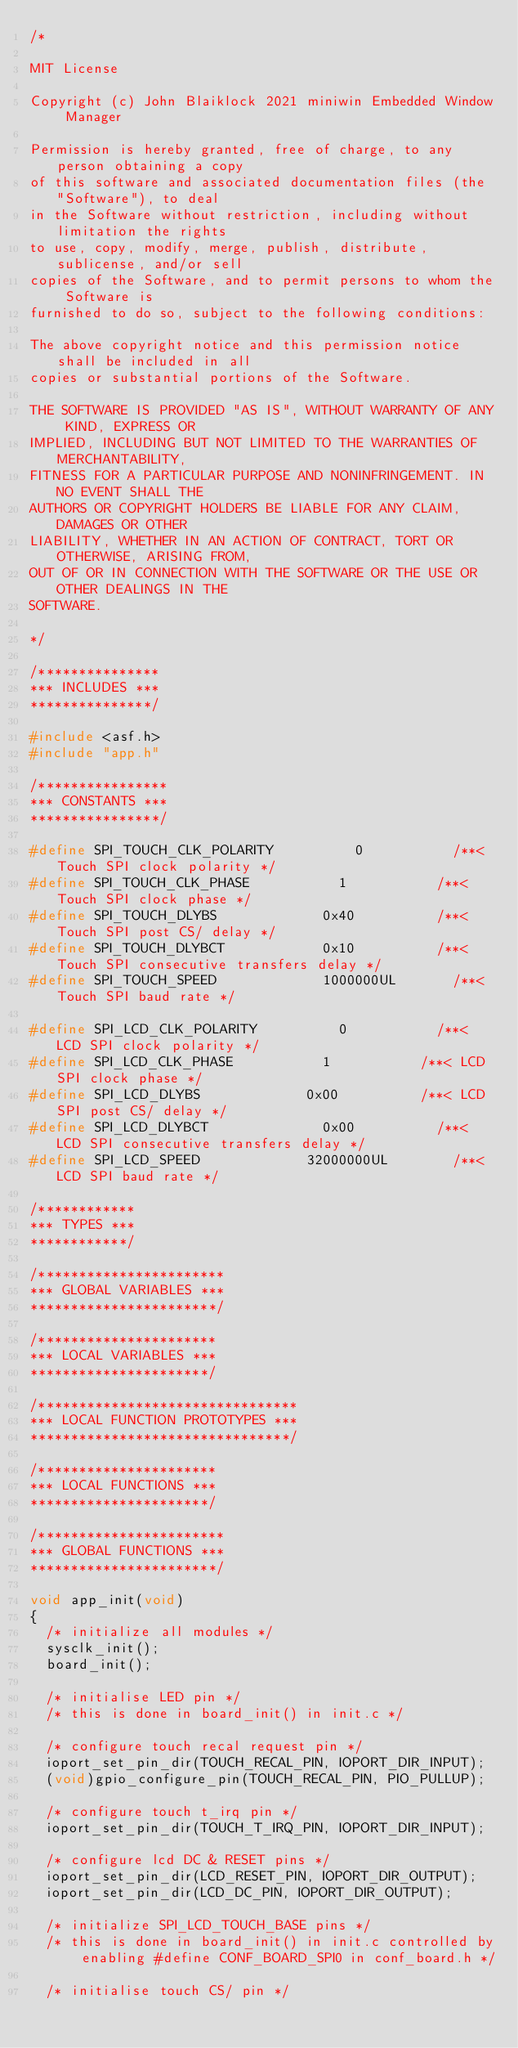<code> <loc_0><loc_0><loc_500><loc_500><_C_>/*

MIT License

Copyright (c) John Blaiklock 2021 miniwin Embedded Window Manager

Permission is hereby granted, free of charge, to any person obtaining a copy
of this software and associated documentation files (the "Software"), to deal
in the Software without restriction, including without limitation the rights
to use, copy, modify, merge, publish, distribute, sublicense, and/or sell
copies of the Software, and to permit persons to whom the Software is
furnished to do so, subject to the following conditions:

The above copyright notice and this permission notice shall be included in all
copies or substantial portions of the Software.

THE SOFTWARE IS PROVIDED "AS IS", WITHOUT WARRANTY OF ANY KIND, EXPRESS OR
IMPLIED, INCLUDING BUT NOT LIMITED TO THE WARRANTIES OF MERCHANTABILITY,
FITNESS FOR A PARTICULAR PURPOSE AND NONINFRINGEMENT. IN NO EVENT SHALL THE
AUTHORS OR COPYRIGHT HOLDERS BE LIABLE FOR ANY CLAIM, DAMAGES OR OTHER
LIABILITY, WHETHER IN AN ACTION OF CONTRACT, TORT OR OTHERWISE, ARISING FROM,
OUT OF OR IN CONNECTION WITH THE SOFTWARE OR THE USE OR OTHER DEALINGS IN THE
SOFTWARE.

*/

/***************
*** INCLUDES ***
***************/

#include <asf.h>
#include "app.h"

/****************
*** CONSTANTS ***
****************/

#define SPI_TOUCH_CLK_POLARITY					0						/**< Touch SPI clock polarity */
#define SPI_TOUCH_CLK_PHASE						1						/**< Touch SPI clock phase */
#define SPI_TOUCH_DLYBS							0x40					/**< Touch SPI post CS/ delay */
#define SPI_TOUCH_DLYBCT						0x10					/**< Touch SPI consecutive transfers delay */
#define SPI_TOUCH_SPEED							1000000UL				/**< Touch SPI baud rate */

#define SPI_LCD_CLK_POLARITY					0						/**< LCD SPI clock polarity */
#define SPI_LCD_CLK_PHASE						1						/**< LCD SPI clock phase */
#define SPI_LCD_DLYBS							0x00					/**< LCD SPI post CS/ delay */
#define SPI_LCD_DLYBCT							0x00					/**< LCD SPI consecutive transfers delay */
#define SPI_LCD_SPEED							32000000UL				/**< LCD SPI baud rate */

/************
*** TYPES ***
************/

/***********************
*** GLOBAL VARIABLES ***
***********************/

/**********************
*** LOCAL VARIABLES ***
**********************/

/********************************
*** LOCAL FUNCTION PROTOTYPES ***
********************************/

/**********************
*** LOCAL FUNCTIONS ***
**********************/

/***********************
*** GLOBAL FUNCTIONS ***
***********************/

void app_init(void)
{
	/* initialize all modules */
	sysclk_init();
	board_init();
	
	/* initialise LED pin */
	/* this is done in board_init() in init.c */
	
	/* configure touch recal request pin */
	ioport_set_pin_dir(TOUCH_RECAL_PIN, IOPORT_DIR_INPUT);
	(void)gpio_configure_pin(TOUCH_RECAL_PIN, PIO_PULLUP);
		
	/* configure touch t_irq pin */
	ioport_set_pin_dir(TOUCH_T_IRQ_PIN, IOPORT_DIR_INPUT);
	
	/* configure lcd DC & RESET pins */
	ioport_set_pin_dir(LCD_RESET_PIN, IOPORT_DIR_OUTPUT);
	ioport_set_pin_dir(LCD_DC_PIN, IOPORT_DIR_OUTPUT);

	/* initialize SPI_LCD_TOUCH_BASE pins */
	/* this is done in board_init() in init.c controlled by enabling #define CONF_BOARD_SPI0 in conf_board.h */
	
	/* initialise touch CS/ pin */</code> 